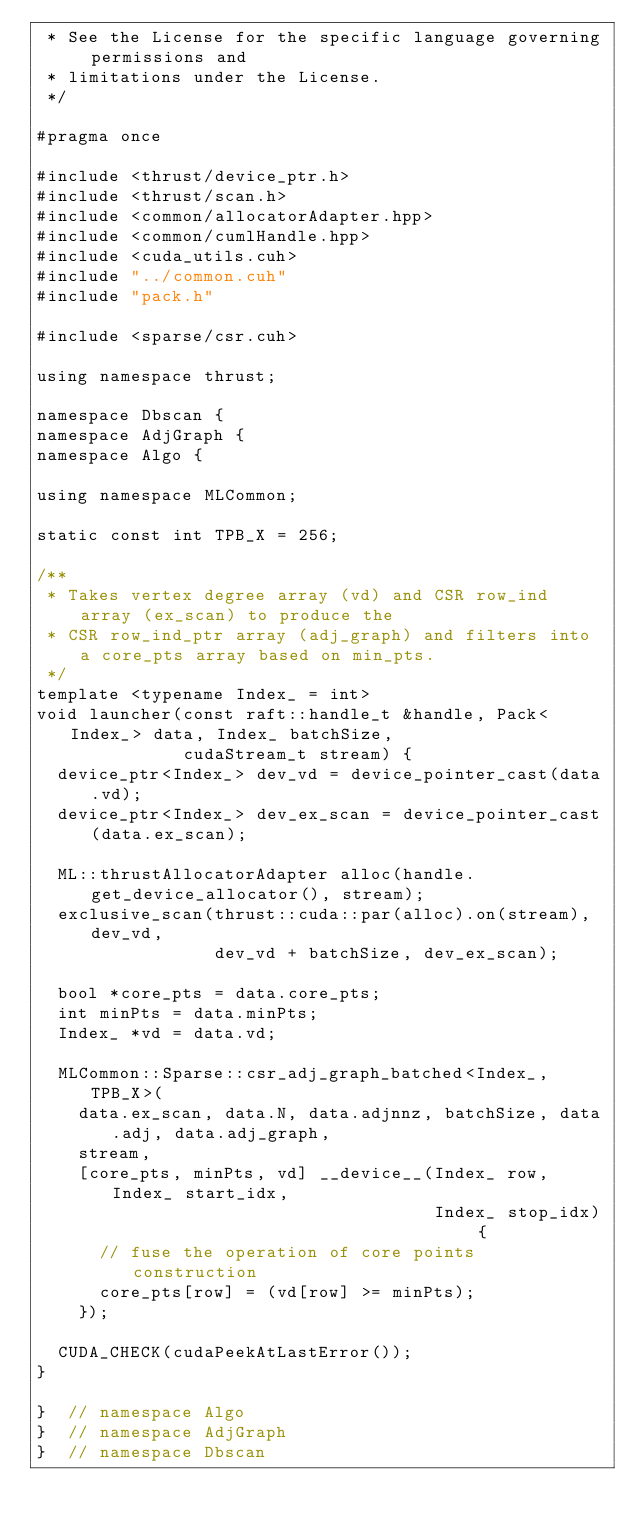<code> <loc_0><loc_0><loc_500><loc_500><_Cuda_> * See the License for the specific language governing permissions and
 * limitations under the License.
 */

#pragma once

#include <thrust/device_ptr.h>
#include <thrust/scan.h>
#include <common/allocatorAdapter.hpp>
#include <common/cumlHandle.hpp>
#include <cuda_utils.cuh>
#include "../common.cuh"
#include "pack.h"

#include <sparse/csr.cuh>

using namespace thrust;

namespace Dbscan {
namespace AdjGraph {
namespace Algo {

using namespace MLCommon;

static const int TPB_X = 256;

/**
 * Takes vertex degree array (vd) and CSR row_ind array (ex_scan) to produce the
 * CSR row_ind_ptr array (adj_graph) and filters into a core_pts array based on min_pts.
 */
template <typename Index_ = int>
void launcher(const raft::handle_t &handle, Pack<Index_> data, Index_ batchSize,
              cudaStream_t stream) {
  device_ptr<Index_> dev_vd = device_pointer_cast(data.vd);
  device_ptr<Index_> dev_ex_scan = device_pointer_cast(data.ex_scan);

  ML::thrustAllocatorAdapter alloc(handle.get_device_allocator(), stream);
  exclusive_scan(thrust::cuda::par(alloc).on(stream), dev_vd,
                 dev_vd + batchSize, dev_ex_scan);

  bool *core_pts = data.core_pts;
  int minPts = data.minPts;
  Index_ *vd = data.vd;

  MLCommon::Sparse::csr_adj_graph_batched<Index_, TPB_X>(
    data.ex_scan, data.N, data.adjnnz, batchSize, data.adj, data.adj_graph,
    stream,
    [core_pts, minPts, vd] __device__(Index_ row, Index_ start_idx,
                                      Index_ stop_idx) {
      // fuse the operation of core points construction
      core_pts[row] = (vd[row] >= minPts);
    });

  CUDA_CHECK(cudaPeekAtLastError());
}

}  // namespace Algo
}  // namespace AdjGraph
}  // namespace Dbscan
</code> 